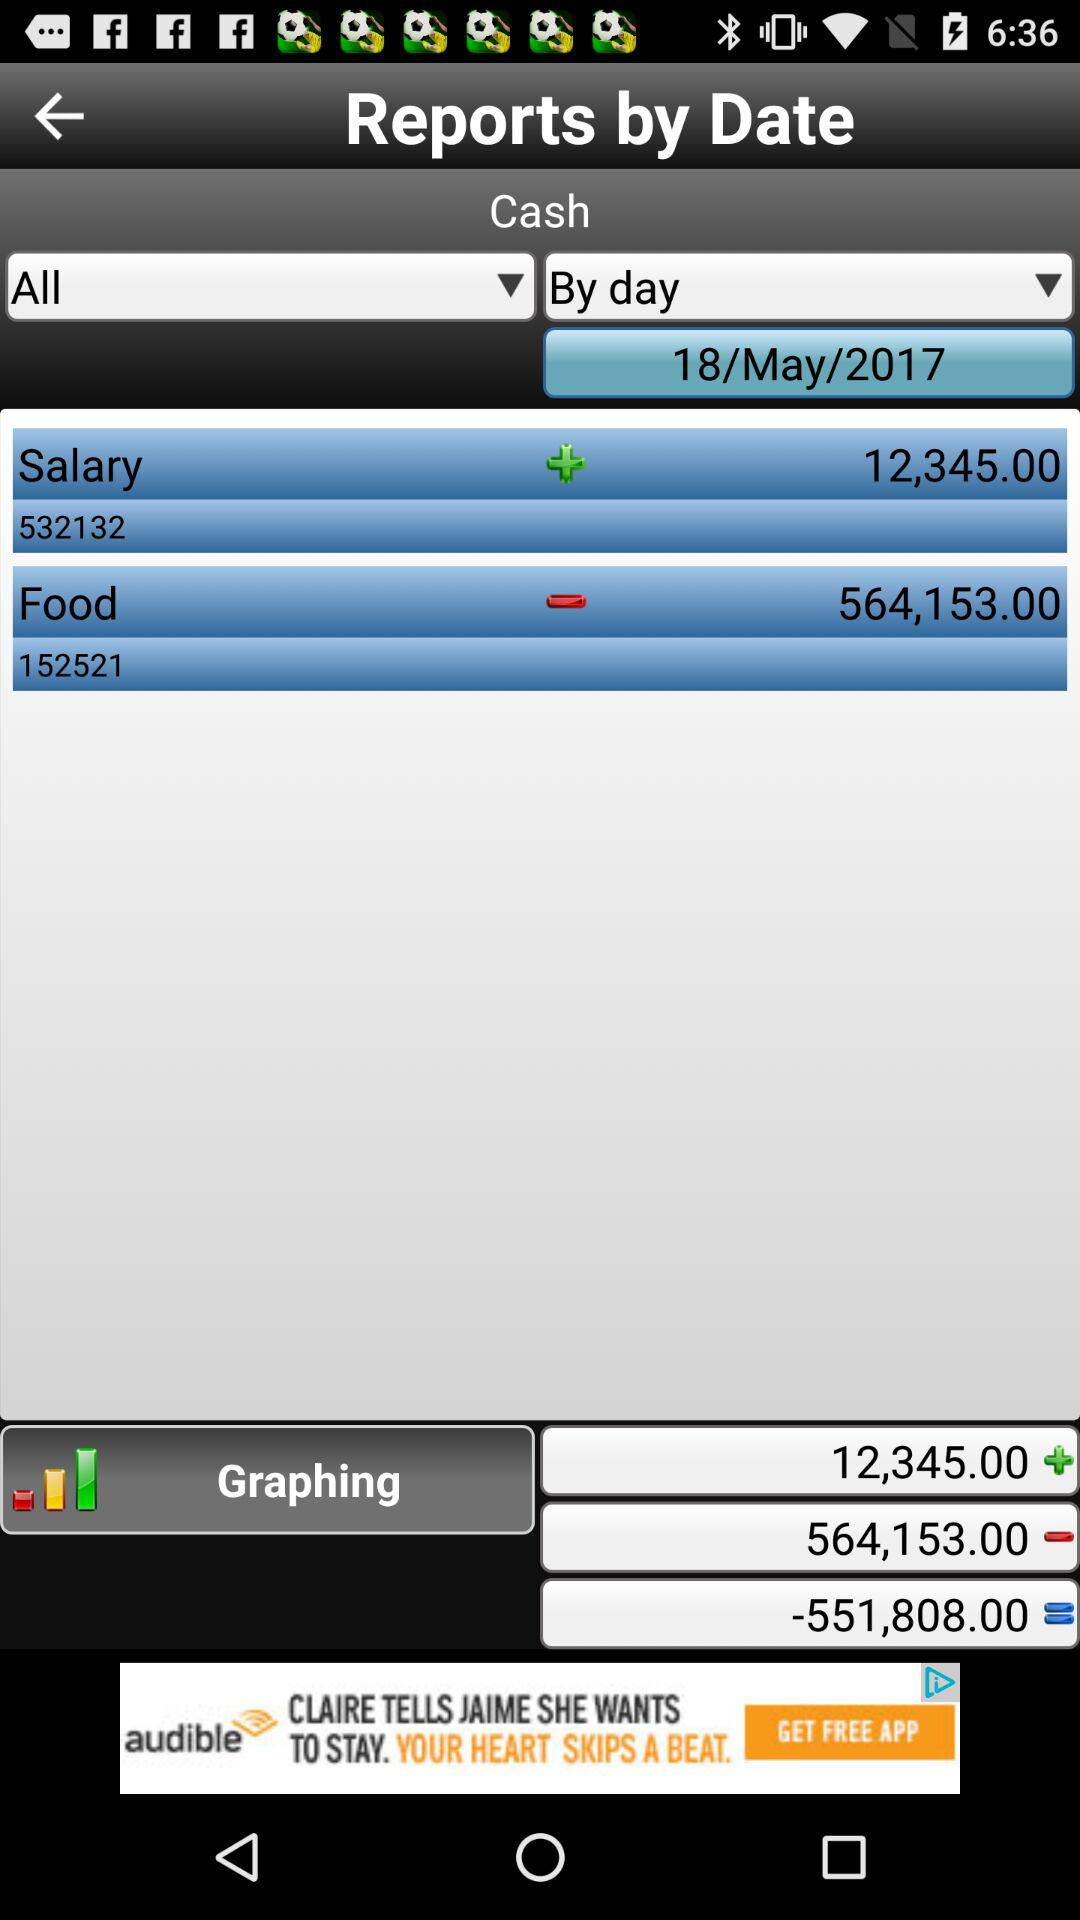What is the total graphing amount? The total graphing amount is -551,808. 